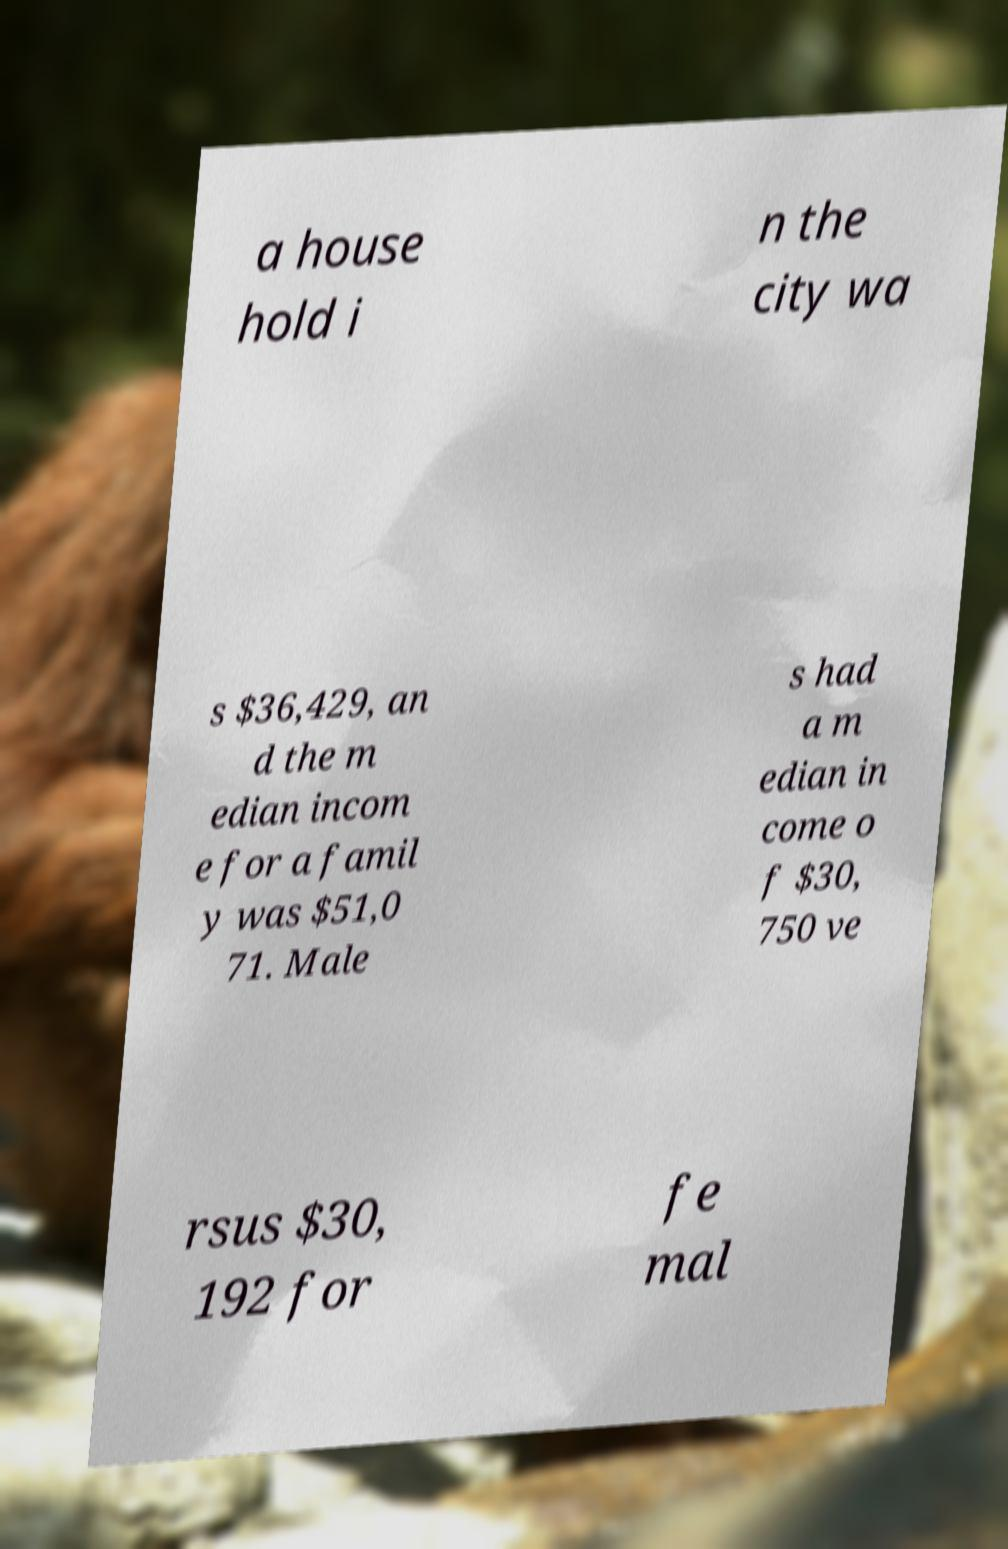Can you accurately transcribe the text from the provided image for me? a house hold i n the city wa s $36,429, an d the m edian incom e for a famil y was $51,0 71. Male s had a m edian in come o f $30, 750 ve rsus $30, 192 for fe mal 